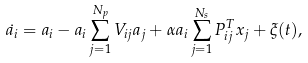<formula> <loc_0><loc_0><loc_500><loc_500>\dot { a _ { i } } = a _ { i } - a _ { i } \sum _ { j = 1 } ^ { N _ { p } } V _ { i j } a _ { j } + \alpha a _ { i } \sum _ { j = 1 } ^ { N _ { s } } P _ { i j } ^ { T } x _ { j } + \xi ( t ) ,</formula> 